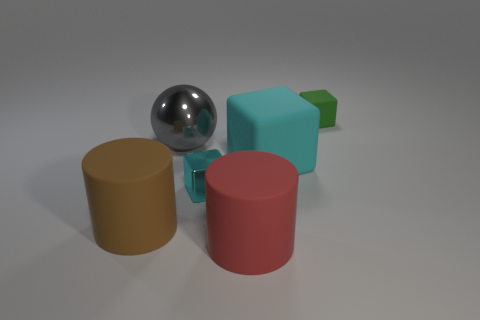Are there any rubber objects on the left side of the cyan rubber thing?
Make the answer very short. Yes. Are there an equal number of metal cubes that are on the right side of the red rubber cylinder and big green blocks?
Give a very brief answer. Yes. There is a cyan thing that is the same size as the brown matte cylinder; what shape is it?
Your answer should be compact. Cube. What is the large red cylinder made of?
Your answer should be very brief. Rubber. There is a large matte thing that is both in front of the shiny cube and to the right of the big brown rubber cylinder; what color is it?
Keep it short and to the point. Red. Are there the same number of big gray metallic things to the left of the large cyan cube and red matte things on the left side of the big brown cylinder?
Offer a very short reply. No. There is a cube that is made of the same material as the gray thing; what color is it?
Give a very brief answer. Cyan. Does the small metallic block have the same color as the large object right of the red thing?
Offer a terse response. Yes. There is a cyan object that is in front of the matte cube on the left side of the small green object; is there a rubber cube that is to the right of it?
Keep it short and to the point. Yes. There is a red object that is made of the same material as the large cyan block; what is its shape?
Offer a very short reply. Cylinder. 